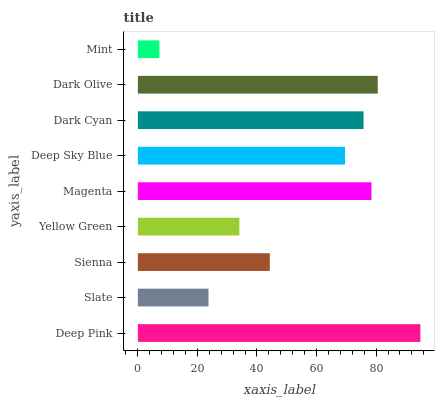Is Mint the minimum?
Answer yes or no. Yes. Is Deep Pink the maximum?
Answer yes or no. Yes. Is Slate the minimum?
Answer yes or no. No. Is Slate the maximum?
Answer yes or no. No. Is Deep Pink greater than Slate?
Answer yes or no. Yes. Is Slate less than Deep Pink?
Answer yes or no. Yes. Is Slate greater than Deep Pink?
Answer yes or no. No. Is Deep Pink less than Slate?
Answer yes or no. No. Is Deep Sky Blue the high median?
Answer yes or no. Yes. Is Deep Sky Blue the low median?
Answer yes or no. Yes. Is Slate the high median?
Answer yes or no. No. Is Dark Cyan the low median?
Answer yes or no. No. 